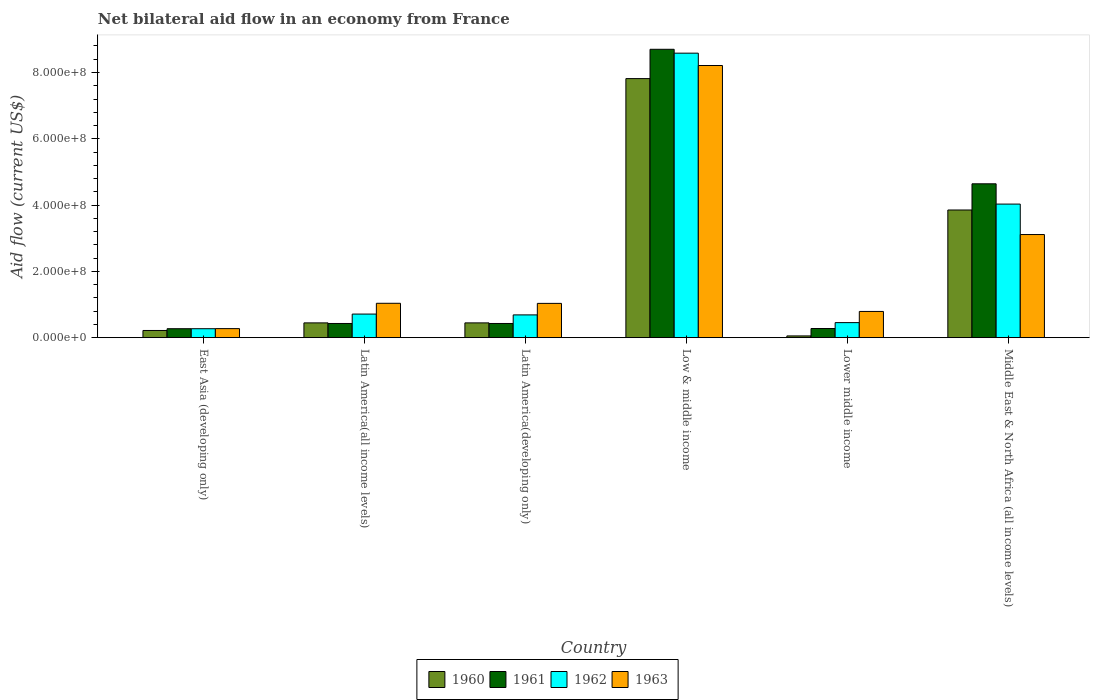How many different coloured bars are there?
Your response must be concise. 4. Are the number of bars per tick equal to the number of legend labels?
Offer a terse response. Yes. Are the number of bars on each tick of the X-axis equal?
Keep it short and to the point. Yes. How many bars are there on the 2nd tick from the left?
Offer a terse response. 4. How many bars are there on the 3rd tick from the right?
Keep it short and to the point. 4. What is the label of the 3rd group of bars from the left?
Your answer should be very brief. Latin America(developing only). What is the net bilateral aid flow in 1962 in Lower middle income?
Offer a very short reply. 4.54e+07. Across all countries, what is the maximum net bilateral aid flow in 1961?
Give a very brief answer. 8.70e+08. Across all countries, what is the minimum net bilateral aid flow in 1960?
Provide a succinct answer. 5.30e+06. In which country was the net bilateral aid flow in 1963 minimum?
Provide a succinct answer. East Asia (developing only). What is the total net bilateral aid flow in 1960 in the graph?
Make the answer very short. 1.28e+09. What is the difference between the net bilateral aid flow in 1960 in Low & middle income and that in Lower middle income?
Make the answer very short. 7.76e+08. What is the difference between the net bilateral aid flow in 1962 in Latin America(all income levels) and the net bilateral aid flow in 1961 in Latin America(developing only)?
Keep it short and to the point. 2.84e+07. What is the average net bilateral aid flow in 1962 per country?
Keep it short and to the point. 2.46e+08. What is the difference between the net bilateral aid flow of/in 1962 and net bilateral aid flow of/in 1960 in Middle East & North Africa (all income levels)?
Your response must be concise. 1.78e+07. What is the ratio of the net bilateral aid flow in 1961 in Low & middle income to that in Lower middle income?
Provide a succinct answer. 31.52. What is the difference between the highest and the second highest net bilateral aid flow in 1962?
Provide a succinct answer. 7.87e+08. What is the difference between the highest and the lowest net bilateral aid flow in 1962?
Make the answer very short. 8.31e+08. In how many countries, is the net bilateral aid flow in 1960 greater than the average net bilateral aid flow in 1960 taken over all countries?
Your response must be concise. 2. Is the sum of the net bilateral aid flow in 1960 in East Asia (developing only) and Lower middle income greater than the maximum net bilateral aid flow in 1961 across all countries?
Make the answer very short. No. Is it the case that in every country, the sum of the net bilateral aid flow in 1961 and net bilateral aid flow in 1960 is greater than the sum of net bilateral aid flow in 1962 and net bilateral aid flow in 1963?
Offer a very short reply. No. What does the 3rd bar from the left in Latin America(developing only) represents?
Provide a succinct answer. 1962. What does the 1st bar from the right in Middle East & North Africa (all income levels) represents?
Give a very brief answer. 1963. Is it the case that in every country, the sum of the net bilateral aid flow in 1960 and net bilateral aid flow in 1961 is greater than the net bilateral aid flow in 1963?
Provide a short and direct response. No. What is the difference between two consecutive major ticks on the Y-axis?
Your response must be concise. 2.00e+08. Does the graph contain any zero values?
Offer a very short reply. No. Does the graph contain grids?
Ensure brevity in your answer.  No. Where does the legend appear in the graph?
Provide a short and direct response. Bottom center. How many legend labels are there?
Give a very brief answer. 4. What is the title of the graph?
Make the answer very short. Net bilateral aid flow in an economy from France. What is the Aid flow (current US$) of 1960 in East Asia (developing only)?
Your response must be concise. 2.17e+07. What is the Aid flow (current US$) in 1961 in East Asia (developing only)?
Your answer should be compact. 2.70e+07. What is the Aid flow (current US$) in 1962 in East Asia (developing only)?
Your response must be concise. 2.70e+07. What is the Aid flow (current US$) of 1963 in East Asia (developing only)?
Ensure brevity in your answer.  2.73e+07. What is the Aid flow (current US$) in 1960 in Latin America(all income levels)?
Keep it short and to the point. 4.46e+07. What is the Aid flow (current US$) of 1961 in Latin America(all income levels)?
Keep it short and to the point. 4.28e+07. What is the Aid flow (current US$) of 1962 in Latin America(all income levels)?
Offer a very short reply. 7.12e+07. What is the Aid flow (current US$) of 1963 in Latin America(all income levels)?
Make the answer very short. 1.04e+08. What is the Aid flow (current US$) of 1960 in Latin America(developing only)?
Your response must be concise. 4.46e+07. What is the Aid flow (current US$) in 1961 in Latin America(developing only)?
Keep it short and to the point. 4.28e+07. What is the Aid flow (current US$) of 1962 in Latin America(developing only)?
Provide a short and direct response. 6.87e+07. What is the Aid flow (current US$) in 1963 in Latin America(developing only)?
Your response must be concise. 1.03e+08. What is the Aid flow (current US$) of 1960 in Low & middle income?
Your answer should be very brief. 7.82e+08. What is the Aid flow (current US$) of 1961 in Low & middle income?
Offer a very short reply. 8.70e+08. What is the Aid flow (current US$) in 1962 in Low & middle income?
Keep it short and to the point. 8.58e+08. What is the Aid flow (current US$) in 1963 in Low & middle income?
Keep it short and to the point. 8.21e+08. What is the Aid flow (current US$) of 1960 in Lower middle income?
Keep it short and to the point. 5.30e+06. What is the Aid flow (current US$) of 1961 in Lower middle income?
Offer a terse response. 2.76e+07. What is the Aid flow (current US$) in 1962 in Lower middle income?
Keep it short and to the point. 4.54e+07. What is the Aid flow (current US$) of 1963 in Lower middle income?
Provide a short and direct response. 7.91e+07. What is the Aid flow (current US$) in 1960 in Middle East & North Africa (all income levels)?
Make the answer very short. 3.85e+08. What is the Aid flow (current US$) in 1961 in Middle East & North Africa (all income levels)?
Give a very brief answer. 4.64e+08. What is the Aid flow (current US$) of 1962 in Middle East & North Africa (all income levels)?
Offer a very short reply. 4.03e+08. What is the Aid flow (current US$) of 1963 in Middle East & North Africa (all income levels)?
Make the answer very short. 3.11e+08. Across all countries, what is the maximum Aid flow (current US$) of 1960?
Your answer should be very brief. 7.82e+08. Across all countries, what is the maximum Aid flow (current US$) of 1961?
Keep it short and to the point. 8.70e+08. Across all countries, what is the maximum Aid flow (current US$) in 1962?
Offer a terse response. 8.58e+08. Across all countries, what is the maximum Aid flow (current US$) of 1963?
Offer a very short reply. 8.21e+08. Across all countries, what is the minimum Aid flow (current US$) in 1960?
Your response must be concise. 5.30e+06. Across all countries, what is the minimum Aid flow (current US$) of 1961?
Make the answer very short. 2.70e+07. Across all countries, what is the minimum Aid flow (current US$) of 1962?
Ensure brevity in your answer.  2.70e+07. Across all countries, what is the minimum Aid flow (current US$) of 1963?
Keep it short and to the point. 2.73e+07. What is the total Aid flow (current US$) in 1960 in the graph?
Keep it short and to the point. 1.28e+09. What is the total Aid flow (current US$) of 1961 in the graph?
Your answer should be compact. 1.47e+09. What is the total Aid flow (current US$) in 1962 in the graph?
Offer a very short reply. 1.47e+09. What is the total Aid flow (current US$) in 1963 in the graph?
Offer a very short reply. 1.45e+09. What is the difference between the Aid flow (current US$) in 1960 in East Asia (developing only) and that in Latin America(all income levels)?
Your response must be concise. -2.29e+07. What is the difference between the Aid flow (current US$) in 1961 in East Asia (developing only) and that in Latin America(all income levels)?
Your answer should be compact. -1.58e+07. What is the difference between the Aid flow (current US$) of 1962 in East Asia (developing only) and that in Latin America(all income levels)?
Make the answer very short. -4.42e+07. What is the difference between the Aid flow (current US$) in 1963 in East Asia (developing only) and that in Latin America(all income levels)?
Provide a succinct answer. -7.64e+07. What is the difference between the Aid flow (current US$) of 1960 in East Asia (developing only) and that in Latin America(developing only)?
Ensure brevity in your answer.  -2.29e+07. What is the difference between the Aid flow (current US$) of 1961 in East Asia (developing only) and that in Latin America(developing only)?
Offer a terse response. -1.58e+07. What is the difference between the Aid flow (current US$) in 1962 in East Asia (developing only) and that in Latin America(developing only)?
Give a very brief answer. -4.17e+07. What is the difference between the Aid flow (current US$) of 1963 in East Asia (developing only) and that in Latin America(developing only)?
Offer a very short reply. -7.61e+07. What is the difference between the Aid flow (current US$) of 1960 in East Asia (developing only) and that in Low & middle income?
Your answer should be compact. -7.60e+08. What is the difference between the Aid flow (current US$) in 1961 in East Asia (developing only) and that in Low & middle income?
Provide a succinct answer. -8.43e+08. What is the difference between the Aid flow (current US$) in 1962 in East Asia (developing only) and that in Low & middle income?
Your response must be concise. -8.31e+08. What is the difference between the Aid flow (current US$) in 1963 in East Asia (developing only) and that in Low & middle income?
Your response must be concise. -7.94e+08. What is the difference between the Aid flow (current US$) of 1960 in East Asia (developing only) and that in Lower middle income?
Offer a terse response. 1.64e+07. What is the difference between the Aid flow (current US$) of 1961 in East Asia (developing only) and that in Lower middle income?
Your answer should be very brief. -6.00e+05. What is the difference between the Aid flow (current US$) of 1962 in East Asia (developing only) and that in Lower middle income?
Offer a very short reply. -1.84e+07. What is the difference between the Aid flow (current US$) of 1963 in East Asia (developing only) and that in Lower middle income?
Your response must be concise. -5.18e+07. What is the difference between the Aid flow (current US$) of 1960 in East Asia (developing only) and that in Middle East & North Africa (all income levels)?
Offer a very short reply. -3.64e+08. What is the difference between the Aid flow (current US$) of 1961 in East Asia (developing only) and that in Middle East & North Africa (all income levels)?
Your answer should be compact. -4.37e+08. What is the difference between the Aid flow (current US$) in 1962 in East Asia (developing only) and that in Middle East & North Africa (all income levels)?
Your response must be concise. -3.76e+08. What is the difference between the Aid flow (current US$) of 1963 in East Asia (developing only) and that in Middle East & North Africa (all income levels)?
Make the answer very short. -2.84e+08. What is the difference between the Aid flow (current US$) in 1960 in Latin America(all income levels) and that in Latin America(developing only)?
Offer a terse response. 0. What is the difference between the Aid flow (current US$) of 1962 in Latin America(all income levels) and that in Latin America(developing only)?
Offer a terse response. 2.50e+06. What is the difference between the Aid flow (current US$) of 1963 in Latin America(all income levels) and that in Latin America(developing only)?
Ensure brevity in your answer.  3.00e+05. What is the difference between the Aid flow (current US$) in 1960 in Latin America(all income levels) and that in Low & middle income?
Keep it short and to the point. -7.37e+08. What is the difference between the Aid flow (current US$) in 1961 in Latin America(all income levels) and that in Low & middle income?
Give a very brief answer. -8.27e+08. What is the difference between the Aid flow (current US$) of 1962 in Latin America(all income levels) and that in Low & middle income?
Offer a very short reply. -7.87e+08. What is the difference between the Aid flow (current US$) of 1963 in Latin America(all income levels) and that in Low & middle income?
Ensure brevity in your answer.  -7.17e+08. What is the difference between the Aid flow (current US$) of 1960 in Latin America(all income levels) and that in Lower middle income?
Keep it short and to the point. 3.93e+07. What is the difference between the Aid flow (current US$) of 1961 in Latin America(all income levels) and that in Lower middle income?
Make the answer very short. 1.52e+07. What is the difference between the Aid flow (current US$) in 1962 in Latin America(all income levels) and that in Lower middle income?
Offer a terse response. 2.58e+07. What is the difference between the Aid flow (current US$) in 1963 in Latin America(all income levels) and that in Lower middle income?
Make the answer very short. 2.46e+07. What is the difference between the Aid flow (current US$) in 1960 in Latin America(all income levels) and that in Middle East & North Africa (all income levels)?
Give a very brief answer. -3.41e+08. What is the difference between the Aid flow (current US$) in 1961 in Latin America(all income levels) and that in Middle East & North Africa (all income levels)?
Your response must be concise. -4.21e+08. What is the difference between the Aid flow (current US$) in 1962 in Latin America(all income levels) and that in Middle East & North Africa (all income levels)?
Keep it short and to the point. -3.32e+08. What is the difference between the Aid flow (current US$) of 1963 in Latin America(all income levels) and that in Middle East & North Africa (all income levels)?
Provide a succinct answer. -2.07e+08. What is the difference between the Aid flow (current US$) in 1960 in Latin America(developing only) and that in Low & middle income?
Keep it short and to the point. -7.37e+08. What is the difference between the Aid flow (current US$) in 1961 in Latin America(developing only) and that in Low & middle income?
Your answer should be very brief. -8.27e+08. What is the difference between the Aid flow (current US$) of 1962 in Latin America(developing only) and that in Low & middle income?
Provide a succinct answer. -7.90e+08. What is the difference between the Aid flow (current US$) of 1963 in Latin America(developing only) and that in Low & middle income?
Provide a short and direct response. -7.18e+08. What is the difference between the Aid flow (current US$) of 1960 in Latin America(developing only) and that in Lower middle income?
Ensure brevity in your answer.  3.93e+07. What is the difference between the Aid flow (current US$) of 1961 in Latin America(developing only) and that in Lower middle income?
Offer a very short reply. 1.52e+07. What is the difference between the Aid flow (current US$) of 1962 in Latin America(developing only) and that in Lower middle income?
Keep it short and to the point. 2.33e+07. What is the difference between the Aid flow (current US$) in 1963 in Latin America(developing only) and that in Lower middle income?
Your answer should be very brief. 2.43e+07. What is the difference between the Aid flow (current US$) in 1960 in Latin America(developing only) and that in Middle East & North Africa (all income levels)?
Keep it short and to the point. -3.41e+08. What is the difference between the Aid flow (current US$) in 1961 in Latin America(developing only) and that in Middle East & North Africa (all income levels)?
Your answer should be compact. -4.21e+08. What is the difference between the Aid flow (current US$) of 1962 in Latin America(developing only) and that in Middle East & North Africa (all income levels)?
Offer a terse response. -3.34e+08. What is the difference between the Aid flow (current US$) of 1963 in Latin America(developing only) and that in Middle East & North Africa (all income levels)?
Your answer should be compact. -2.08e+08. What is the difference between the Aid flow (current US$) of 1960 in Low & middle income and that in Lower middle income?
Your response must be concise. 7.76e+08. What is the difference between the Aid flow (current US$) of 1961 in Low & middle income and that in Lower middle income?
Your response must be concise. 8.42e+08. What is the difference between the Aid flow (current US$) in 1962 in Low & middle income and that in Lower middle income?
Provide a short and direct response. 8.13e+08. What is the difference between the Aid flow (current US$) of 1963 in Low & middle income and that in Lower middle income?
Your answer should be compact. 7.42e+08. What is the difference between the Aid flow (current US$) of 1960 in Low & middle income and that in Middle East & North Africa (all income levels)?
Offer a terse response. 3.96e+08. What is the difference between the Aid flow (current US$) of 1961 in Low & middle income and that in Middle East & North Africa (all income levels)?
Give a very brief answer. 4.06e+08. What is the difference between the Aid flow (current US$) of 1962 in Low & middle income and that in Middle East & North Africa (all income levels)?
Offer a very short reply. 4.55e+08. What is the difference between the Aid flow (current US$) of 1963 in Low & middle income and that in Middle East & North Africa (all income levels)?
Provide a short and direct response. 5.10e+08. What is the difference between the Aid flow (current US$) of 1960 in Lower middle income and that in Middle East & North Africa (all income levels)?
Give a very brief answer. -3.80e+08. What is the difference between the Aid flow (current US$) of 1961 in Lower middle income and that in Middle East & North Africa (all income levels)?
Make the answer very short. -4.37e+08. What is the difference between the Aid flow (current US$) of 1962 in Lower middle income and that in Middle East & North Africa (all income levels)?
Provide a short and direct response. -3.58e+08. What is the difference between the Aid flow (current US$) of 1963 in Lower middle income and that in Middle East & North Africa (all income levels)?
Keep it short and to the point. -2.32e+08. What is the difference between the Aid flow (current US$) in 1960 in East Asia (developing only) and the Aid flow (current US$) in 1961 in Latin America(all income levels)?
Keep it short and to the point. -2.11e+07. What is the difference between the Aid flow (current US$) of 1960 in East Asia (developing only) and the Aid flow (current US$) of 1962 in Latin America(all income levels)?
Keep it short and to the point. -4.95e+07. What is the difference between the Aid flow (current US$) in 1960 in East Asia (developing only) and the Aid flow (current US$) in 1963 in Latin America(all income levels)?
Offer a terse response. -8.20e+07. What is the difference between the Aid flow (current US$) in 1961 in East Asia (developing only) and the Aid flow (current US$) in 1962 in Latin America(all income levels)?
Your answer should be very brief. -4.42e+07. What is the difference between the Aid flow (current US$) of 1961 in East Asia (developing only) and the Aid flow (current US$) of 1963 in Latin America(all income levels)?
Ensure brevity in your answer.  -7.67e+07. What is the difference between the Aid flow (current US$) of 1962 in East Asia (developing only) and the Aid flow (current US$) of 1963 in Latin America(all income levels)?
Give a very brief answer. -7.67e+07. What is the difference between the Aid flow (current US$) of 1960 in East Asia (developing only) and the Aid flow (current US$) of 1961 in Latin America(developing only)?
Ensure brevity in your answer.  -2.11e+07. What is the difference between the Aid flow (current US$) in 1960 in East Asia (developing only) and the Aid flow (current US$) in 1962 in Latin America(developing only)?
Provide a succinct answer. -4.70e+07. What is the difference between the Aid flow (current US$) of 1960 in East Asia (developing only) and the Aid flow (current US$) of 1963 in Latin America(developing only)?
Ensure brevity in your answer.  -8.17e+07. What is the difference between the Aid flow (current US$) in 1961 in East Asia (developing only) and the Aid flow (current US$) in 1962 in Latin America(developing only)?
Your answer should be compact. -4.17e+07. What is the difference between the Aid flow (current US$) of 1961 in East Asia (developing only) and the Aid flow (current US$) of 1963 in Latin America(developing only)?
Provide a succinct answer. -7.64e+07. What is the difference between the Aid flow (current US$) of 1962 in East Asia (developing only) and the Aid flow (current US$) of 1963 in Latin America(developing only)?
Make the answer very short. -7.64e+07. What is the difference between the Aid flow (current US$) of 1960 in East Asia (developing only) and the Aid flow (current US$) of 1961 in Low & middle income?
Offer a very short reply. -8.48e+08. What is the difference between the Aid flow (current US$) in 1960 in East Asia (developing only) and the Aid flow (current US$) in 1962 in Low & middle income?
Provide a succinct answer. -8.37e+08. What is the difference between the Aid flow (current US$) in 1960 in East Asia (developing only) and the Aid flow (current US$) in 1963 in Low & middle income?
Give a very brief answer. -7.99e+08. What is the difference between the Aid flow (current US$) of 1961 in East Asia (developing only) and the Aid flow (current US$) of 1962 in Low & middle income?
Provide a short and direct response. -8.31e+08. What is the difference between the Aid flow (current US$) in 1961 in East Asia (developing only) and the Aid flow (current US$) in 1963 in Low & middle income?
Your answer should be very brief. -7.94e+08. What is the difference between the Aid flow (current US$) in 1962 in East Asia (developing only) and the Aid flow (current US$) in 1963 in Low & middle income?
Make the answer very short. -7.94e+08. What is the difference between the Aid flow (current US$) of 1960 in East Asia (developing only) and the Aid flow (current US$) of 1961 in Lower middle income?
Make the answer very short. -5.90e+06. What is the difference between the Aid flow (current US$) in 1960 in East Asia (developing only) and the Aid flow (current US$) in 1962 in Lower middle income?
Offer a very short reply. -2.37e+07. What is the difference between the Aid flow (current US$) in 1960 in East Asia (developing only) and the Aid flow (current US$) in 1963 in Lower middle income?
Provide a short and direct response. -5.74e+07. What is the difference between the Aid flow (current US$) in 1961 in East Asia (developing only) and the Aid flow (current US$) in 1962 in Lower middle income?
Offer a terse response. -1.84e+07. What is the difference between the Aid flow (current US$) of 1961 in East Asia (developing only) and the Aid flow (current US$) of 1963 in Lower middle income?
Offer a terse response. -5.21e+07. What is the difference between the Aid flow (current US$) of 1962 in East Asia (developing only) and the Aid flow (current US$) of 1963 in Lower middle income?
Offer a very short reply. -5.21e+07. What is the difference between the Aid flow (current US$) in 1960 in East Asia (developing only) and the Aid flow (current US$) in 1961 in Middle East & North Africa (all income levels)?
Offer a terse response. -4.42e+08. What is the difference between the Aid flow (current US$) in 1960 in East Asia (developing only) and the Aid flow (current US$) in 1962 in Middle East & North Africa (all income levels)?
Make the answer very short. -3.81e+08. What is the difference between the Aid flow (current US$) of 1960 in East Asia (developing only) and the Aid flow (current US$) of 1963 in Middle East & North Africa (all income levels)?
Your response must be concise. -2.89e+08. What is the difference between the Aid flow (current US$) of 1961 in East Asia (developing only) and the Aid flow (current US$) of 1962 in Middle East & North Africa (all income levels)?
Your answer should be very brief. -3.76e+08. What is the difference between the Aid flow (current US$) of 1961 in East Asia (developing only) and the Aid flow (current US$) of 1963 in Middle East & North Africa (all income levels)?
Your answer should be very brief. -2.84e+08. What is the difference between the Aid flow (current US$) in 1962 in East Asia (developing only) and the Aid flow (current US$) in 1963 in Middle East & North Africa (all income levels)?
Ensure brevity in your answer.  -2.84e+08. What is the difference between the Aid flow (current US$) of 1960 in Latin America(all income levels) and the Aid flow (current US$) of 1961 in Latin America(developing only)?
Make the answer very short. 1.80e+06. What is the difference between the Aid flow (current US$) of 1960 in Latin America(all income levels) and the Aid flow (current US$) of 1962 in Latin America(developing only)?
Offer a terse response. -2.41e+07. What is the difference between the Aid flow (current US$) of 1960 in Latin America(all income levels) and the Aid flow (current US$) of 1963 in Latin America(developing only)?
Your answer should be very brief. -5.88e+07. What is the difference between the Aid flow (current US$) in 1961 in Latin America(all income levels) and the Aid flow (current US$) in 1962 in Latin America(developing only)?
Your answer should be compact. -2.59e+07. What is the difference between the Aid flow (current US$) in 1961 in Latin America(all income levels) and the Aid flow (current US$) in 1963 in Latin America(developing only)?
Keep it short and to the point. -6.06e+07. What is the difference between the Aid flow (current US$) of 1962 in Latin America(all income levels) and the Aid flow (current US$) of 1963 in Latin America(developing only)?
Keep it short and to the point. -3.22e+07. What is the difference between the Aid flow (current US$) in 1960 in Latin America(all income levels) and the Aid flow (current US$) in 1961 in Low & middle income?
Make the answer very short. -8.25e+08. What is the difference between the Aid flow (current US$) in 1960 in Latin America(all income levels) and the Aid flow (current US$) in 1962 in Low & middle income?
Offer a terse response. -8.14e+08. What is the difference between the Aid flow (current US$) in 1960 in Latin America(all income levels) and the Aid flow (current US$) in 1963 in Low & middle income?
Provide a short and direct response. -7.76e+08. What is the difference between the Aid flow (current US$) of 1961 in Latin America(all income levels) and the Aid flow (current US$) of 1962 in Low & middle income?
Offer a very short reply. -8.16e+08. What is the difference between the Aid flow (current US$) in 1961 in Latin America(all income levels) and the Aid flow (current US$) in 1963 in Low & middle income?
Ensure brevity in your answer.  -7.78e+08. What is the difference between the Aid flow (current US$) of 1962 in Latin America(all income levels) and the Aid flow (current US$) of 1963 in Low & middle income?
Provide a short and direct response. -7.50e+08. What is the difference between the Aid flow (current US$) of 1960 in Latin America(all income levels) and the Aid flow (current US$) of 1961 in Lower middle income?
Your answer should be very brief. 1.70e+07. What is the difference between the Aid flow (current US$) of 1960 in Latin America(all income levels) and the Aid flow (current US$) of 1962 in Lower middle income?
Make the answer very short. -8.00e+05. What is the difference between the Aid flow (current US$) of 1960 in Latin America(all income levels) and the Aid flow (current US$) of 1963 in Lower middle income?
Your response must be concise. -3.45e+07. What is the difference between the Aid flow (current US$) in 1961 in Latin America(all income levels) and the Aid flow (current US$) in 1962 in Lower middle income?
Provide a succinct answer. -2.60e+06. What is the difference between the Aid flow (current US$) in 1961 in Latin America(all income levels) and the Aid flow (current US$) in 1963 in Lower middle income?
Your answer should be compact. -3.63e+07. What is the difference between the Aid flow (current US$) of 1962 in Latin America(all income levels) and the Aid flow (current US$) of 1963 in Lower middle income?
Offer a very short reply. -7.90e+06. What is the difference between the Aid flow (current US$) of 1960 in Latin America(all income levels) and the Aid flow (current US$) of 1961 in Middle East & North Africa (all income levels)?
Offer a terse response. -4.20e+08. What is the difference between the Aid flow (current US$) in 1960 in Latin America(all income levels) and the Aid flow (current US$) in 1962 in Middle East & North Africa (all income levels)?
Offer a terse response. -3.58e+08. What is the difference between the Aid flow (current US$) in 1960 in Latin America(all income levels) and the Aid flow (current US$) in 1963 in Middle East & North Africa (all income levels)?
Your answer should be compact. -2.66e+08. What is the difference between the Aid flow (current US$) of 1961 in Latin America(all income levels) and the Aid flow (current US$) of 1962 in Middle East & North Africa (all income levels)?
Keep it short and to the point. -3.60e+08. What is the difference between the Aid flow (current US$) of 1961 in Latin America(all income levels) and the Aid flow (current US$) of 1963 in Middle East & North Africa (all income levels)?
Provide a short and direct response. -2.68e+08. What is the difference between the Aid flow (current US$) in 1962 in Latin America(all income levels) and the Aid flow (current US$) in 1963 in Middle East & North Africa (all income levels)?
Your response must be concise. -2.40e+08. What is the difference between the Aid flow (current US$) in 1960 in Latin America(developing only) and the Aid flow (current US$) in 1961 in Low & middle income?
Provide a succinct answer. -8.25e+08. What is the difference between the Aid flow (current US$) in 1960 in Latin America(developing only) and the Aid flow (current US$) in 1962 in Low & middle income?
Ensure brevity in your answer.  -8.14e+08. What is the difference between the Aid flow (current US$) in 1960 in Latin America(developing only) and the Aid flow (current US$) in 1963 in Low & middle income?
Your response must be concise. -7.76e+08. What is the difference between the Aid flow (current US$) of 1961 in Latin America(developing only) and the Aid flow (current US$) of 1962 in Low & middle income?
Provide a succinct answer. -8.16e+08. What is the difference between the Aid flow (current US$) of 1961 in Latin America(developing only) and the Aid flow (current US$) of 1963 in Low & middle income?
Keep it short and to the point. -7.78e+08. What is the difference between the Aid flow (current US$) in 1962 in Latin America(developing only) and the Aid flow (current US$) in 1963 in Low & middle income?
Offer a very short reply. -7.52e+08. What is the difference between the Aid flow (current US$) of 1960 in Latin America(developing only) and the Aid flow (current US$) of 1961 in Lower middle income?
Provide a short and direct response. 1.70e+07. What is the difference between the Aid flow (current US$) in 1960 in Latin America(developing only) and the Aid flow (current US$) in 1962 in Lower middle income?
Keep it short and to the point. -8.00e+05. What is the difference between the Aid flow (current US$) in 1960 in Latin America(developing only) and the Aid flow (current US$) in 1963 in Lower middle income?
Your answer should be very brief. -3.45e+07. What is the difference between the Aid flow (current US$) in 1961 in Latin America(developing only) and the Aid flow (current US$) in 1962 in Lower middle income?
Offer a terse response. -2.60e+06. What is the difference between the Aid flow (current US$) of 1961 in Latin America(developing only) and the Aid flow (current US$) of 1963 in Lower middle income?
Offer a very short reply. -3.63e+07. What is the difference between the Aid flow (current US$) of 1962 in Latin America(developing only) and the Aid flow (current US$) of 1963 in Lower middle income?
Provide a succinct answer. -1.04e+07. What is the difference between the Aid flow (current US$) in 1960 in Latin America(developing only) and the Aid flow (current US$) in 1961 in Middle East & North Africa (all income levels)?
Provide a short and direct response. -4.20e+08. What is the difference between the Aid flow (current US$) of 1960 in Latin America(developing only) and the Aid flow (current US$) of 1962 in Middle East & North Africa (all income levels)?
Ensure brevity in your answer.  -3.58e+08. What is the difference between the Aid flow (current US$) in 1960 in Latin America(developing only) and the Aid flow (current US$) in 1963 in Middle East & North Africa (all income levels)?
Offer a terse response. -2.66e+08. What is the difference between the Aid flow (current US$) of 1961 in Latin America(developing only) and the Aid flow (current US$) of 1962 in Middle East & North Africa (all income levels)?
Keep it short and to the point. -3.60e+08. What is the difference between the Aid flow (current US$) in 1961 in Latin America(developing only) and the Aid flow (current US$) in 1963 in Middle East & North Africa (all income levels)?
Keep it short and to the point. -2.68e+08. What is the difference between the Aid flow (current US$) of 1962 in Latin America(developing only) and the Aid flow (current US$) of 1963 in Middle East & North Africa (all income levels)?
Offer a very short reply. -2.42e+08. What is the difference between the Aid flow (current US$) of 1960 in Low & middle income and the Aid flow (current US$) of 1961 in Lower middle income?
Ensure brevity in your answer.  7.54e+08. What is the difference between the Aid flow (current US$) of 1960 in Low & middle income and the Aid flow (current US$) of 1962 in Lower middle income?
Make the answer very short. 7.36e+08. What is the difference between the Aid flow (current US$) of 1960 in Low & middle income and the Aid flow (current US$) of 1963 in Lower middle income?
Provide a short and direct response. 7.02e+08. What is the difference between the Aid flow (current US$) of 1961 in Low & middle income and the Aid flow (current US$) of 1962 in Lower middle income?
Provide a succinct answer. 8.25e+08. What is the difference between the Aid flow (current US$) in 1961 in Low & middle income and the Aid flow (current US$) in 1963 in Lower middle income?
Make the answer very short. 7.91e+08. What is the difference between the Aid flow (current US$) of 1962 in Low & middle income and the Aid flow (current US$) of 1963 in Lower middle income?
Your answer should be very brief. 7.79e+08. What is the difference between the Aid flow (current US$) in 1960 in Low & middle income and the Aid flow (current US$) in 1961 in Middle East & North Africa (all income levels)?
Provide a succinct answer. 3.17e+08. What is the difference between the Aid flow (current US$) in 1960 in Low & middle income and the Aid flow (current US$) in 1962 in Middle East & North Africa (all income levels)?
Offer a very short reply. 3.79e+08. What is the difference between the Aid flow (current US$) of 1960 in Low & middle income and the Aid flow (current US$) of 1963 in Middle East & North Africa (all income levels)?
Offer a very short reply. 4.70e+08. What is the difference between the Aid flow (current US$) in 1961 in Low & middle income and the Aid flow (current US$) in 1962 in Middle East & North Africa (all income levels)?
Provide a short and direct response. 4.67e+08. What is the difference between the Aid flow (current US$) in 1961 in Low & middle income and the Aid flow (current US$) in 1963 in Middle East & North Africa (all income levels)?
Give a very brief answer. 5.59e+08. What is the difference between the Aid flow (current US$) in 1962 in Low & middle income and the Aid flow (current US$) in 1963 in Middle East & North Africa (all income levels)?
Make the answer very short. 5.47e+08. What is the difference between the Aid flow (current US$) in 1960 in Lower middle income and the Aid flow (current US$) in 1961 in Middle East & North Africa (all income levels)?
Your answer should be very brief. -4.59e+08. What is the difference between the Aid flow (current US$) in 1960 in Lower middle income and the Aid flow (current US$) in 1962 in Middle East & North Africa (all income levels)?
Keep it short and to the point. -3.98e+08. What is the difference between the Aid flow (current US$) in 1960 in Lower middle income and the Aid flow (current US$) in 1963 in Middle East & North Africa (all income levels)?
Offer a terse response. -3.06e+08. What is the difference between the Aid flow (current US$) in 1961 in Lower middle income and the Aid flow (current US$) in 1962 in Middle East & North Africa (all income levels)?
Offer a very short reply. -3.75e+08. What is the difference between the Aid flow (current US$) of 1961 in Lower middle income and the Aid flow (current US$) of 1963 in Middle East & North Africa (all income levels)?
Provide a succinct answer. -2.84e+08. What is the difference between the Aid flow (current US$) of 1962 in Lower middle income and the Aid flow (current US$) of 1963 in Middle East & North Africa (all income levels)?
Ensure brevity in your answer.  -2.66e+08. What is the average Aid flow (current US$) in 1960 per country?
Your answer should be compact. 2.14e+08. What is the average Aid flow (current US$) of 1961 per country?
Keep it short and to the point. 2.46e+08. What is the average Aid flow (current US$) in 1962 per country?
Your response must be concise. 2.46e+08. What is the average Aid flow (current US$) in 1963 per country?
Your answer should be very brief. 2.41e+08. What is the difference between the Aid flow (current US$) of 1960 and Aid flow (current US$) of 1961 in East Asia (developing only)?
Give a very brief answer. -5.30e+06. What is the difference between the Aid flow (current US$) in 1960 and Aid flow (current US$) in 1962 in East Asia (developing only)?
Your response must be concise. -5.30e+06. What is the difference between the Aid flow (current US$) of 1960 and Aid flow (current US$) of 1963 in East Asia (developing only)?
Keep it short and to the point. -5.60e+06. What is the difference between the Aid flow (current US$) in 1961 and Aid flow (current US$) in 1963 in East Asia (developing only)?
Make the answer very short. -3.00e+05. What is the difference between the Aid flow (current US$) of 1962 and Aid flow (current US$) of 1963 in East Asia (developing only)?
Give a very brief answer. -3.00e+05. What is the difference between the Aid flow (current US$) of 1960 and Aid flow (current US$) of 1961 in Latin America(all income levels)?
Keep it short and to the point. 1.80e+06. What is the difference between the Aid flow (current US$) of 1960 and Aid flow (current US$) of 1962 in Latin America(all income levels)?
Provide a succinct answer. -2.66e+07. What is the difference between the Aid flow (current US$) in 1960 and Aid flow (current US$) in 1963 in Latin America(all income levels)?
Give a very brief answer. -5.91e+07. What is the difference between the Aid flow (current US$) in 1961 and Aid flow (current US$) in 1962 in Latin America(all income levels)?
Provide a short and direct response. -2.84e+07. What is the difference between the Aid flow (current US$) of 1961 and Aid flow (current US$) of 1963 in Latin America(all income levels)?
Make the answer very short. -6.09e+07. What is the difference between the Aid flow (current US$) of 1962 and Aid flow (current US$) of 1963 in Latin America(all income levels)?
Offer a very short reply. -3.25e+07. What is the difference between the Aid flow (current US$) of 1960 and Aid flow (current US$) of 1961 in Latin America(developing only)?
Your answer should be very brief. 1.80e+06. What is the difference between the Aid flow (current US$) of 1960 and Aid flow (current US$) of 1962 in Latin America(developing only)?
Offer a very short reply. -2.41e+07. What is the difference between the Aid flow (current US$) in 1960 and Aid flow (current US$) in 1963 in Latin America(developing only)?
Ensure brevity in your answer.  -5.88e+07. What is the difference between the Aid flow (current US$) in 1961 and Aid flow (current US$) in 1962 in Latin America(developing only)?
Ensure brevity in your answer.  -2.59e+07. What is the difference between the Aid flow (current US$) in 1961 and Aid flow (current US$) in 1963 in Latin America(developing only)?
Your response must be concise. -6.06e+07. What is the difference between the Aid flow (current US$) of 1962 and Aid flow (current US$) of 1963 in Latin America(developing only)?
Make the answer very short. -3.47e+07. What is the difference between the Aid flow (current US$) in 1960 and Aid flow (current US$) in 1961 in Low & middle income?
Provide a succinct answer. -8.84e+07. What is the difference between the Aid flow (current US$) of 1960 and Aid flow (current US$) of 1962 in Low & middle income?
Offer a very short reply. -7.67e+07. What is the difference between the Aid flow (current US$) of 1960 and Aid flow (current US$) of 1963 in Low & middle income?
Offer a very short reply. -3.95e+07. What is the difference between the Aid flow (current US$) in 1961 and Aid flow (current US$) in 1962 in Low & middle income?
Offer a terse response. 1.17e+07. What is the difference between the Aid flow (current US$) of 1961 and Aid flow (current US$) of 1963 in Low & middle income?
Offer a terse response. 4.89e+07. What is the difference between the Aid flow (current US$) in 1962 and Aid flow (current US$) in 1963 in Low & middle income?
Keep it short and to the point. 3.72e+07. What is the difference between the Aid flow (current US$) of 1960 and Aid flow (current US$) of 1961 in Lower middle income?
Give a very brief answer. -2.23e+07. What is the difference between the Aid flow (current US$) in 1960 and Aid flow (current US$) in 1962 in Lower middle income?
Provide a succinct answer. -4.01e+07. What is the difference between the Aid flow (current US$) of 1960 and Aid flow (current US$) of 1963 in Lower middle income?
Make the answer very short. -7.38e+07. What is the difference between the Aid flow (current US$) in 1961 and Aid flow (current US$) in 1962 in Lower middle income?
Your response must be concise. -1.78e+07. What is the difference between the Aid flow (current US$) of 1961 and Aid flow (current US$) of 1963 in Lower middle income?
Offer a terse response. -5.15e+07. What is the difference between the Aid flow (current US$) of 1962 and Aid flow (current US$) of 1963 in Lower middle income?
Ensure brevity in your answer.  -3.37e+07. What is the difference between the Aid flow (current US$) of 1960 and Aid flow (current US$) of 1961 in Middle East & North Africa (all income levels)?
Provide a short and direct response. -7.90e+07. What is the difference between the Aid flow (current US$) in 1960 and Aid flow (current US$) in 1962 in Middle East & North Africa (all income levels)?
Offer a very short reply. -1.78e+07. What is the difference between the Aid flow (current US$) in 1960 and Aid flow (current US$) in 1963 in Middle East & North Africa (all income levels)?
Your answer should be compact. 7.41e+07. What is the difference between the Aid flow (current US$) of 1961 and Aid flow (current US$) of 1962 in Middle East & North Africa (all income levels)?
Give a very brief answer. 6.12e+07. What is the difference between the Aid flow (current US$) in 1961 and Aid flow (current US$) in 1963 in Middle East & North Africa (all income levels)?
Give a very brief answer. 1.53e+08. What is the difference between the Aid flow (current US$) of 1962 and Aid flow (current US$) of 1963 in Middle East & North Africa (all income levels)?
Provide a short and direct response. 9.19e+07. What is the ratio of the Aid flow (current US$) in 1960 in East Asia (developing only) to that in Latin America(all income levels)?
Provide a short and direct response. 0.49. What is the ratio of the Aid flow (current US$) in 1961 in East Asia (developing only) to that in Latin America(all income levels)?
Keep it short and to the point. 0.63. What is the ratio of the Aid flow (current US$) of 1962 in East Asia (developing only) to that in Latin America(all income levels)?
Your response must be concise. 0.38. What is the ratio of the Aid flow (current US$) in 1963 in East Asia (developing only) to that in Latin America(all income levels)?
Offer a terse response. 0.26. What is the ratio of the Aid flow (current US$) in 1960 in East Asia (developing only) to that in Latin America(developing only)?
Your response must be concise. 0.49. What is the ratio of the Aid flow (current US$) in 1961 in East Asia (developing only) to that in Latin America(developing only)?
Give a very brief answer. 0.63. What is the ratio of the Aid flow (current US$) of 1962 in East Asia (developing only) to that in Latin America(developing only)?
Ensure brevity in your answer.  0.39. What is the ratio of the Aid flow (current US$) of 1963 in East Asia (developing only) to that in Latin America(developing only)?
Give a very brief answer. 0.26. What is the ratio of the Aid flow (current US$) in 1960 in East Asia (developing only) to that in Low & middle income?
Give a very brief answer. 0.03. What is the ratio of the Aid flow (current US$) in 1961 in East Asia (developing only) to that in Low & middle income?
Your answer should be very brief. 0.03. What is the ratio of the Aid flow (current US$) in 1962 in East Asia (developing only) to that in Low & middle income?
Your response must be concise. 0.03. What is the ratio of the Aid flow (current US$) of 1963 in East Asia (developing only) to that in Low & middle income?
Your response must be concise. 0.03. What is the ratio of the Aid flow (current US$) of 1960 in East Asia (developing only) to that in Lower middle income?
Your response must be concise. 4.09. What is the ratio of the Aid flow (current US$) of 1961 in East Asia (developing only) to that in Lower middle income?
Give a very brief answer. 0.98. What is the ratio of the Aid flow (current US$) in 1962 in East Asia (developing only) to that in Lower middle income?
Keep it short and to the point. 0.59. What is the ratio of the Aid flow (current US$) of 1963 in East Asia (developing only) to that in Lower middle income?
Give a very brief answer. 0.35. What is the ratio of the Aid flow (current US$) of 1960 in East Asia (developing only) to that in Middle East & North Africa (all income levels)?
Your answer should be very brief. 0.06. What is the ratio of the Aid flow (current US$) of 1961 in East Asia (developing only) to that in Middle East & North Africa (all income levels)?
Give a very brief answer. 0.06. What is the ratio of the Aid flow (current US$) of 1962 in East Asia (developing only) to that in Middle East & North Africa (all income levels)?
Keep it short and to the point. 0.07. What is the ratio of the Aid flow (current US$) in 1963 in East Asia (developing only) to that in Middle East & North Africa (all income levels)?
Your answer should be compact. 0.09. What is the ratio of the Aid flow (current US$) in 1960 in Latin America(all income levels) to that in Latin America(developing only)?
Provide a short and direct response. 1. What is the ratio of the Aid flow (current US$) of 1962 in Latin America(all income levels) to that in Latin America(developing only)?
Give a very brief answer. 1.04. What is the ratio of the Aid flow (current US$) of 1960 in Latin America(all income levels) to that in Low & middle income?
Offer a very short reply. 0.06. What is the ratio of the Aid flow (current US$) of 1961 in Latin America(all income levels) to that in Low & middle income?
Your answer should be compact. 0.05. What is the ratio of the Aid flow (current US$) in 1962 in Latin America(all income levels) to that in Low & middle income?
Your answer should be compact. 0.08. What is the ratio of the Aid flow (current US$) in 1963 in Latin America(all income levels) to that in Low & middle income?
Offer a very short reply. 0.13. What is the ratio of the Aid flow (current US$) of 1960 in Latin America(all income levels) to that in Lower middle income?
Offer a very short reply. 8.42. What is the ratio of the Aid flow (current US$) of 1961 in Latin America(all income levels) to that in Lower middle income?
Ensure brevity in your answer.  1.55. What is the ratio of the Aid flow (current US$) in 1962 in Latin America(all income levels) to that in Lower middle income?
Provide a short and direct response. 1.57. What is the ratio of the Aid flow (current US$) in 1963 in Latin America(all income levels) to that in Lower middle income?
Your answer should be compact. 1.31. What is the ratio of the Aid flow (current US$) in 1960 in Latin America(all income levels) to that in Middle East & North Africa (all income levels)?
Offer a terse response. 0.12. What is the ratio of the Aid flow (current US$) of 1961 in Latin America(all income levels) to that in Middle East & North Africa (all income levels)?
Your response must be concise. 0.09. What is the ratio of the Aid flow (current US$) of 1962 in Latin America(all income levels) to that in Middle East & North Africa (all income levels)?
Ensure brevity in your answer.  0.18. What is the ratio of the Aid flow (current US$) in 1960 in Latin America(developing only) to that in Low & middle income?
Ensure brevity in your answer.  0.06. What is the ratio of the Aid flow (current US$) of 1961 in Latin America(developing only) to that in Low & middle income?
Make the answer very short. 0.05. What is the ratio of the Aid flow (current US$) of 1963 in Latin America(developing only) to that in Low & middle income?
Offer a very short reply. 0.13. What is the ratio of the Aid flow (current US$) of 1960 in Latin America(developing only) to that in Lower middle income?
Provide a short and direct response. 8.42. What is the ratio of the Aid flow (current US$) in 1961 in Latin America(developing only) to that in Lower middle income?
Offer a very short reply. 1.55. What is the ratio of the Aid flow (current US$) of 1962 in Latin America(developing only) to that in Lower middle income?
Your answer should be compact. 1.51. What is the ratio of the Aid flow (current US$) in 1963 in Latin America(developing only) to that in Lower middle income?
Provide a succinct answer. 1.31. What is the ratio of the Aid flow (current US$) in 1960 in Latin America(developing only) to that in Middle East & North Africa (all income levels)?
Your response must be concise. 0.12. What is the ratio of the Aid flow (current US$) in 1961 in Latin America(developing only) to that in Middle East & North Africa (all income levels)?
Give a very brief answer. 0.09. What is the ratio of the Aid flow (current US$) in 1962 in Latin America(developing only) to that in Middle East & North Africa (all income levels)?
Your answer should be very brief. 0.17. What is the ratio of the Aid flow (current US$) in 1963 in Latin America(developing only) to that in Middle East & North Africa (all income levels)?
Your answer should be compact. 0.33. What is the ratio of the Aid flow (current US$) in 1960 in Low & middle income to that in Lower middle income?
Provide a short and direct response. 147.47. What is the ratio of the Aid flow (current US$) of 1961 in Low & middle income to that in Lower middle income?
Give a very brief answer. 31.52. What is the ratio of the Aid flow (current US$) of 1962 in Low & middle income to that in Lower middle income?
Your response must be concise. 18.91. What is the ratio of the Aid flow (current US$) in 1963 in Low & middle income to that in Lower middle income?
Your answer should be compact. 10.38. What is the ratio of the Aid flow (current US$) in 1960 in Low & middle income to that in Middle East & North Africa (all income levels)?
Provide a short and direct response. 2.03. What is the ratio of the Aid flow (current US$) of 1961 in Low & middle income to that in Middle East & North Africa (all income levels)?
Keep it short and to the point. 1.87. What is the ratio of the Aid flow (current US$) of 1962 in Low & middle income to that in Middle East & North Africa (all income levels)?
Your response must be concise. 2.13. What is the ratio of the Aid flow (current US$) in 1963 in Low & middle income to that in Middle East & North Africa (all income levels)?
Ensure brevity in your answer.  2.64. What is the ratio of the Aid flow (current US$) in 1960 in Lower middle income to that in Middle East & North Africa (all income levels)?
Keep it short and to the point. 0.01. What is the ratio of the Aid flow (current US$) in 1961 in Lower middle income to that in Middle East & North Africa (all income levels)?
Your response must be concise. 0.06. What is the ratio of the Aid flow (current US$) of 1962 in Lower middle income to that in Middle East & North Africa (all income levels)?
Keep it short and to the point. 0.11. What is the ratio of the Aid flow (current US$) of 1963 in Lower middle income to that in Middle East & North Africa (all income levels)?
Keep it short and to the point. 0.25. What is the difference between the highest and the second highest Aid flow (current US$) in 1960?
Make the answer very short. 3.96e+08. What is the difference between the highest and the second highest Aid flow (current US$) of 1961?
Offer a very short reply. 4.06e+08. What is the difference between the highest and the second highest Aid flow (current US$) in 1962?
Ensure brevity in your answer.  4.55e+08. What is the difference between the highest and the second highest Aid flow (current US$) in 1963?
Ensure brevity in your answer.  5.10e+08. What is the difference between the highest and the lowest Aid flow (current US$) in 1960?
Ensure brevity in your answer.  7.76e+08. What is the difference between the highest and the lowest Aid flow (current US$) of 1961?
Provide a succinct answer. 8.43e+08. What is the difference between the highest and the lowest Aid flow (current US$) in 1962?
Your answer should be compact. 8.31e+08. What is the difference between the highest and the lowest Aid flow (current US$) of 1963?
Provide a short and direct response. 7.94e+08. 